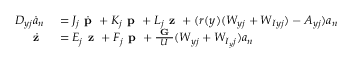<formula> <loc_0><loc_0><loc_500><loc_500>\begin{array} { r l } { D _ { y j } \dot { a } _ { n } } & = J _ { j } \dot { p } + K _ { j } p + L _ { j } z + ( r ( y ) ( W _ { y j } + W _ { I y j } ) - A _ { y j } ) a _ { n } } \\ { \dot { z } } & = E _ { j } z + F _ { j } p + \frac { G } { U } ( W _ { y j } + W _ { I _ { y } j } ) a _ { n } } \end{array}</formula> 